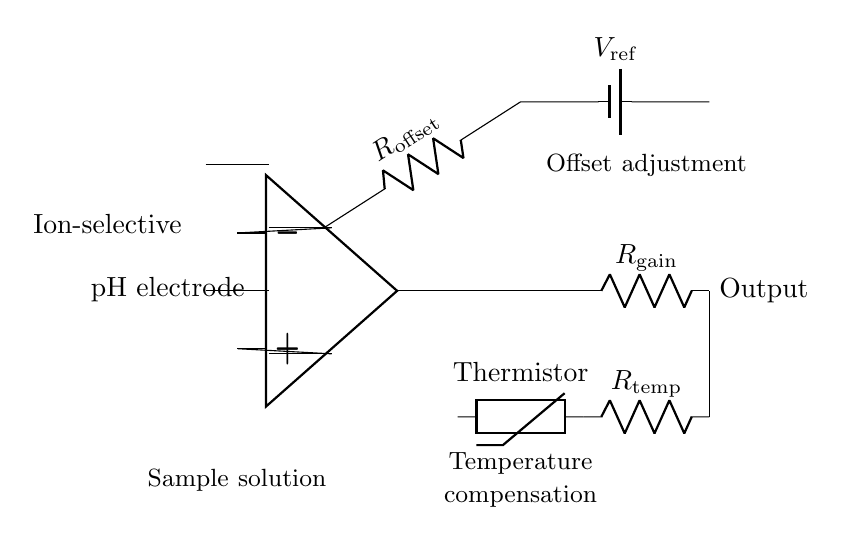What type of electrodes are used in this circuit? The circuit uses an ion-selective electrode and a pH electrode, as indicated by the labels in the diagram.
Answer: Ion-selective and pH What component converts the signal from the electrodes? The instrumentation amplifier converts the signal from the ion-selective and pH electrodes to a usable level, facilitating accurate measurement.
Answer: Instrumentation amplifier What is the role of the thermistor in this circuit? The thermistor provides temperature compensation to ensure accurate pH measurements, as temperature variations can affect electrode readings.
Answer: Temperature compensation What is the reference voltage source in this circuit called? The reference voltage source is labeled as V ref and is crucial for offset adjustment in the amplification process.
Answer: V ref How many resistors are present in the offset adjustment section? There is one resistor labeled as R offset in the offset adjustment section connected to the reference voltage source.
Answer: One What is the output of this pH measurement circuit? The output is taken from the op amp, with the connection leading to a resistor labeled as R gain, indicating that it will output a scaled signal according to the amplification factor.
Answer: Output 